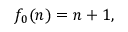Convert formula to latex. <formula><loc_0><loc_0><loc_500><loc_500>f _ { 0 } ( n ) = n + 1 ,</formula> 